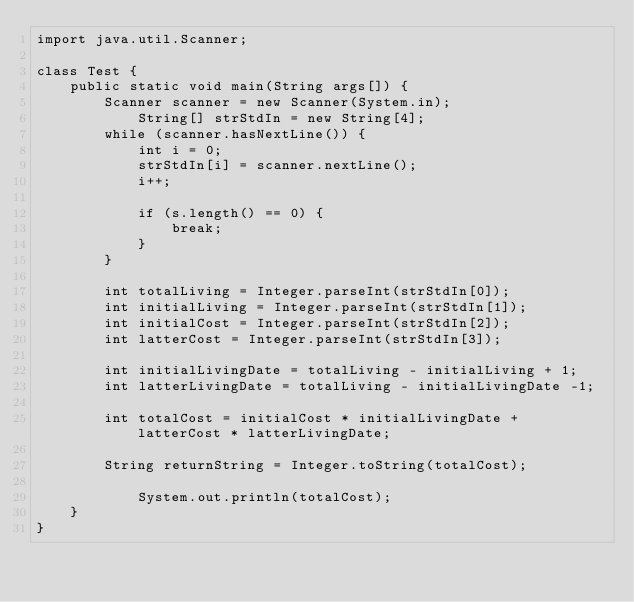<code> <loc_0><loc_0><loc_500><loc_500><_Java_>import java.util.Scanner;

class Test {
	public static void main(String args[]) {
		Scanner scanner = new Scanner(System.in);
       		String[] strStdIn = new String[4];
		while (scanner.hasNextLine()) {
			int i = 0;
			strStdIn[i] = scanner.nextLine();
			i++;

			if (s.length() == 0) {
				break;
			}
		}

		int totalLiving = Integer.parseInt(strStdIn[0]);
		int initialLiving = Integer.parseInt(strStdIn[1]);
		int initialCost = Integer.parseInt(strStdIn[2]);
		int latterCost = Integer.parseInt(strStdIn[3]);
		
		int initialLivingDate = totalLiving - initialLiving + 1;
		int latterLivingDate = totalLiving - initialLivingDate -1;

		int totalCost = initialCost * initialLivingDate + latterCost * latterLivingDate;

		String returnString = Integer.toString(totalCost);

        	System.out.println(totalCost);
    }
}</code> 